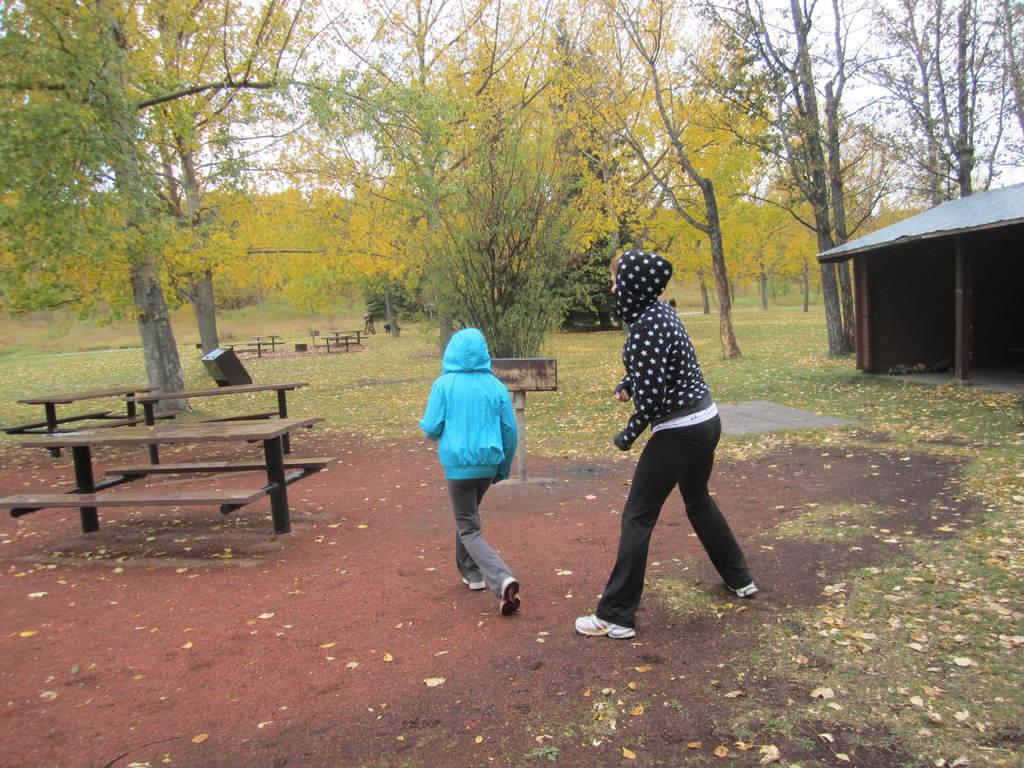How would you summarize this image in a sentence or two? In this image I see two persons who are on the path and there are benches over here, I also can also see the grass, a shed and the trees. 